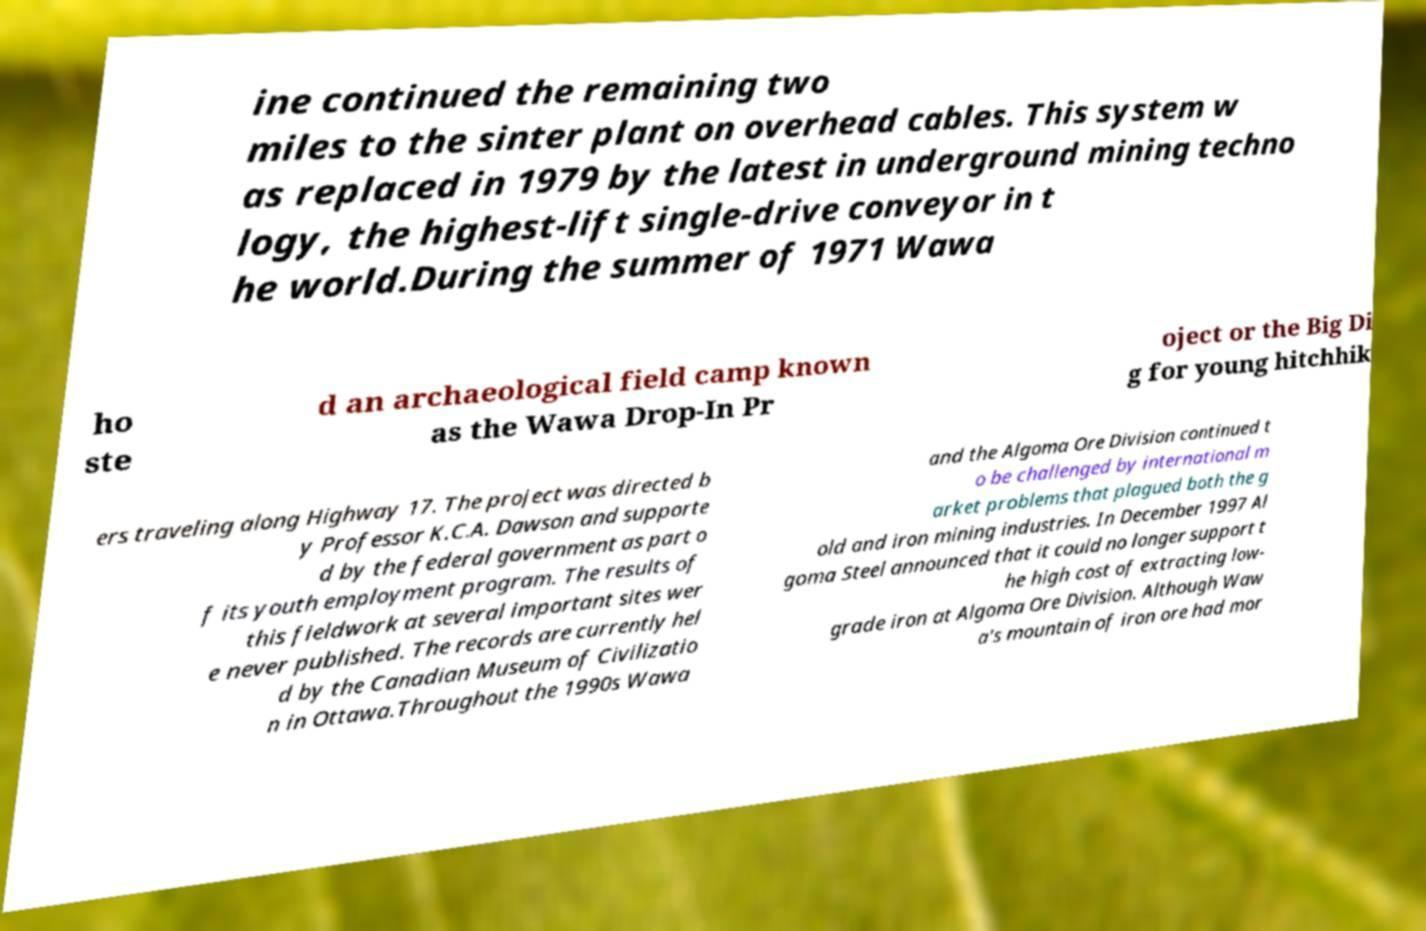I need the written content from this picture converted into text. Can you do that? ine continued the remaining two miles to the sinter plant on overhead cables. This system w as replaced in 1979 by the latest in underground mining techno logy, the highest-lift single-drive conveyor in t he world.During the summer of 1971 Wawa ho ste d an archaeological field camp known as the Wawa Drop-In Pr oject or the Big Di g for young hitchhik ers traveling along Highway 17. The project was directed b y Professor K.C.A. Dawson and supporte d by the federal government as part o f its youth employment program. The results of this fieldwork at several important sites wer e never published. The records are currently hel d by the Canadian Museum of Civilizatio n in Ottawa.Throughout the 1990s Wawa and the Algoma Ore Division continued t o be challenged by international m arket problems that plagued both the g old and iron mining industries. In December 1997 Al goma Steel announced that it could no longer support t he high cost of extracting low- grade iron at Algoma Ore Division. Although Waw a's mountain of iron ore had mor 